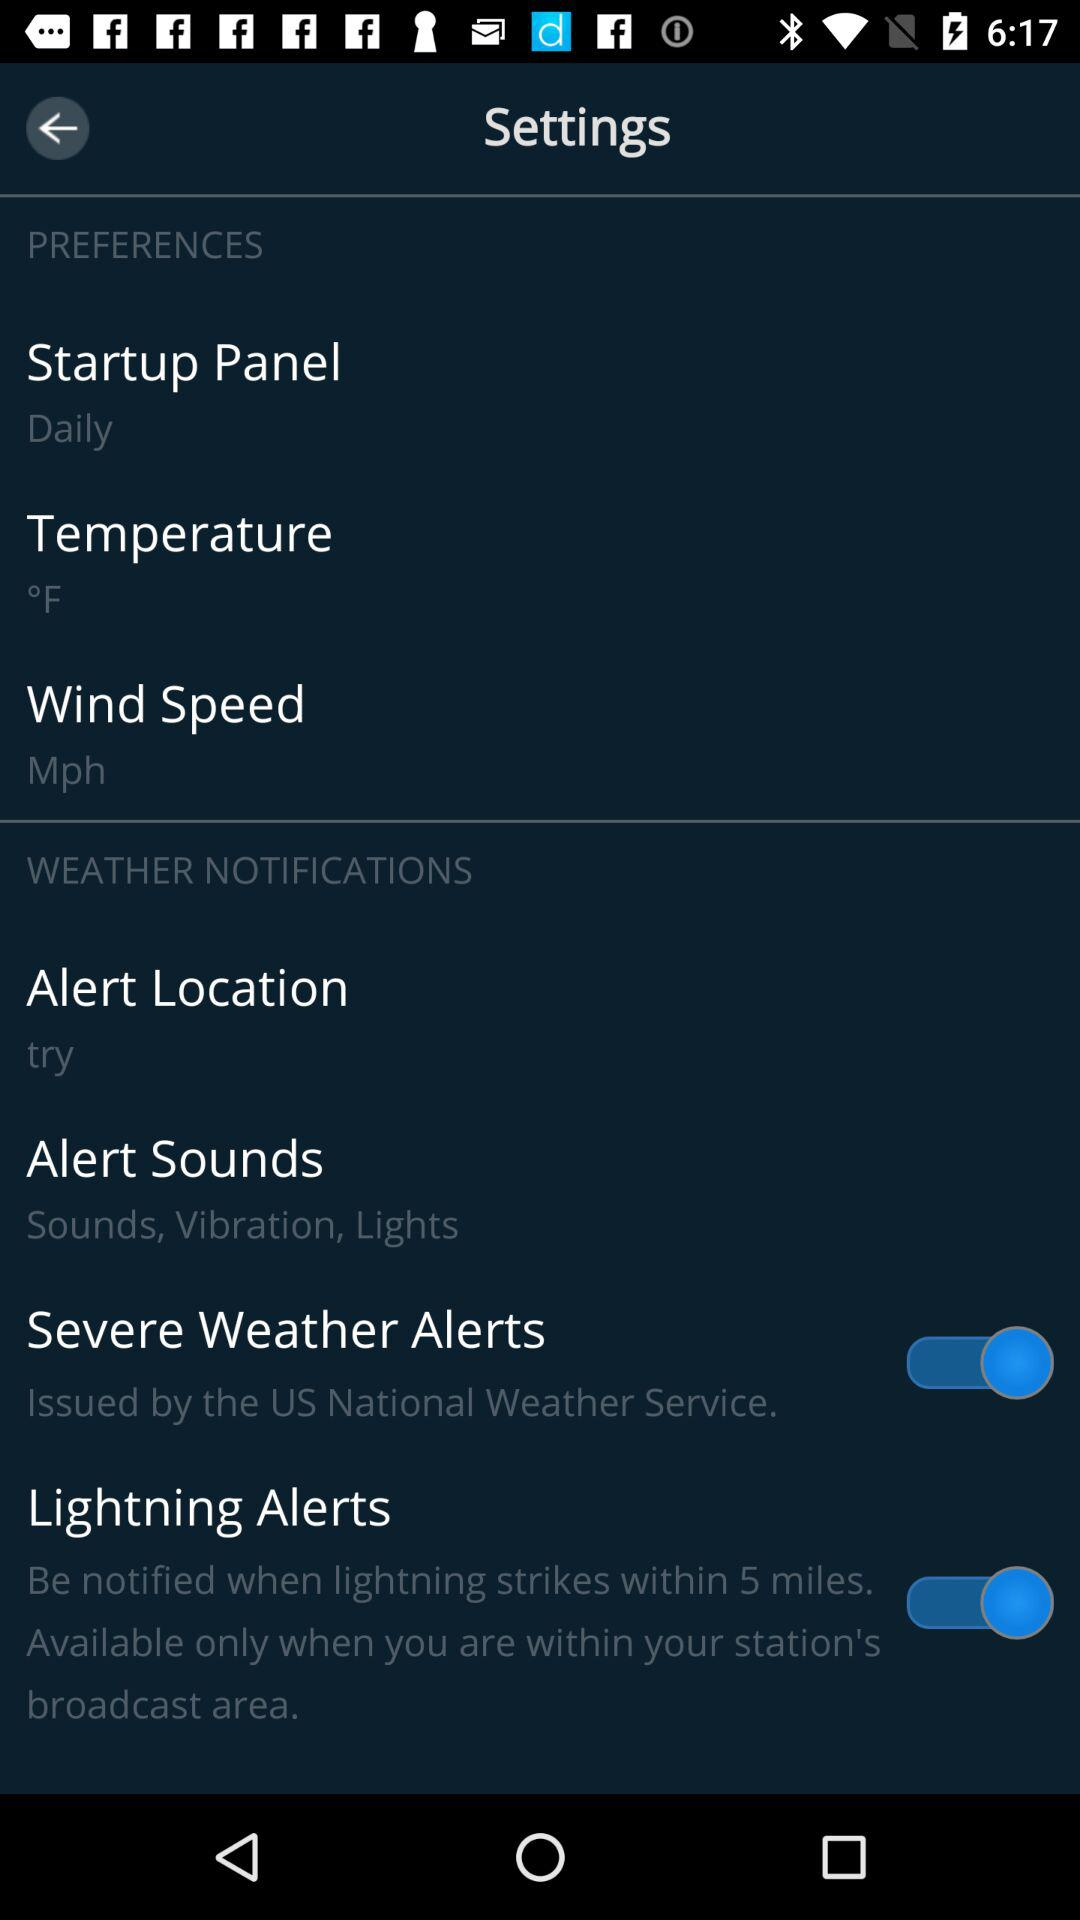What is the status of the "Lightning Alerts"? The status of the "Lightning Alerts" is "on". 